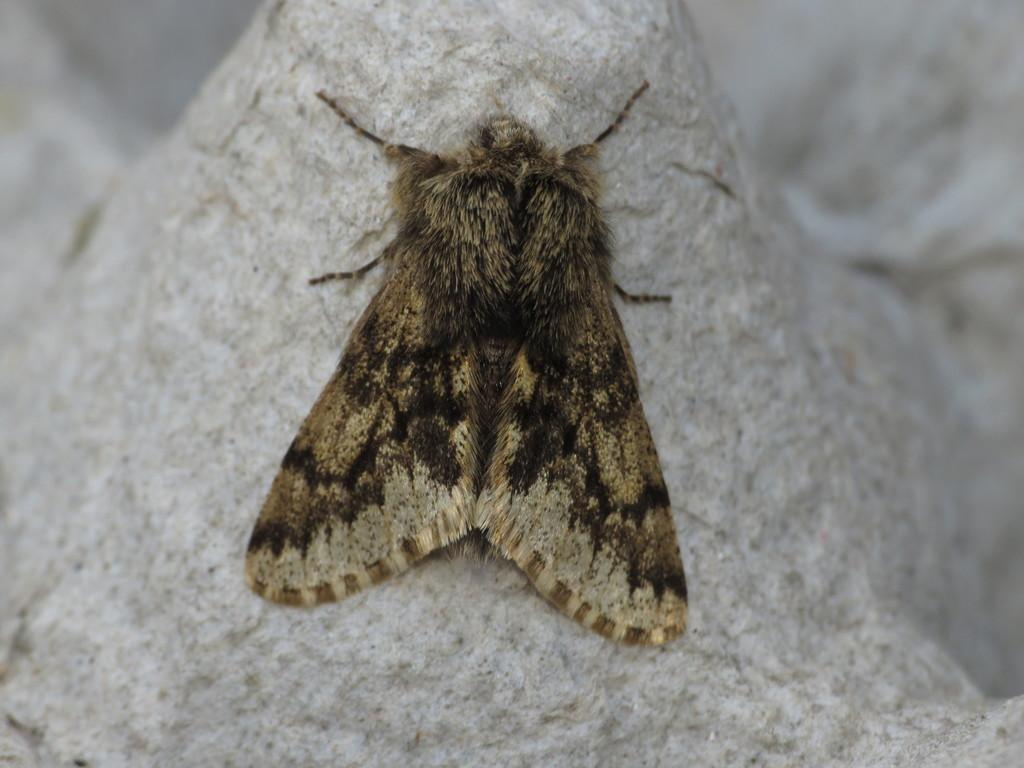What is the main subject of the picture? The main subject of the picture is a bug. Can you describe the colors of the bug? The bug has brown and black colors. Where is the bug located in the image? The bug is sitting on a stone. How would you describe the background of the image? The background of the image is blurred. What type of trouble is the bug causing in the image? There is no indication in the image that the bug is causing any trouble. 